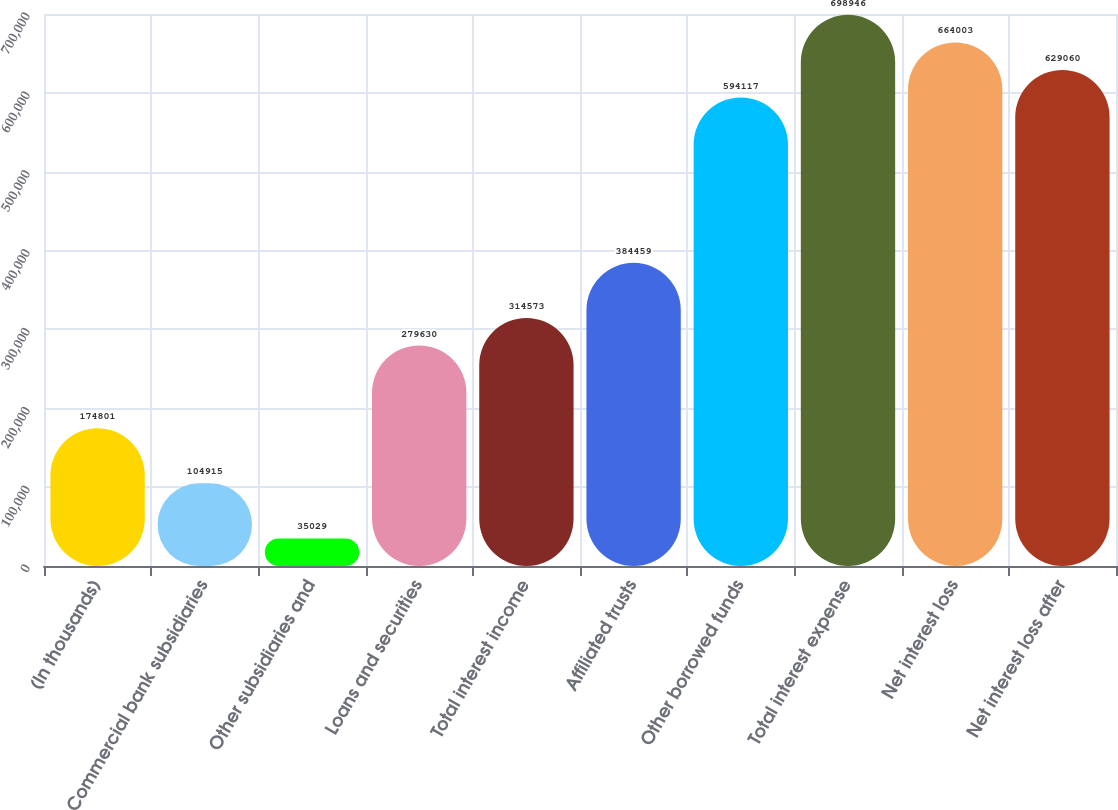Convert chart to OTSL. <chart><loc_0><loc_0><loc_500><loc_500><bar_chart><fcel>(In thousands)<fcel>Commercial bank subsidiaries<fcel>Other subsidiaries and<fcel>Loans and securities<fcel>Total interest income<fcel>Affiliated trusts<fcel>Other borrowed funds<fcel>Total interest expense<fcel>Net interest loss<fcel>Net interest loss after<nl><fcel>174801<fcel>104915<fcel>35029<fcel>279630<fcel>314573<fcel>384459<fcel>594117<fcel>698946<fcel>664003<fcel>629060<nl></chart> 